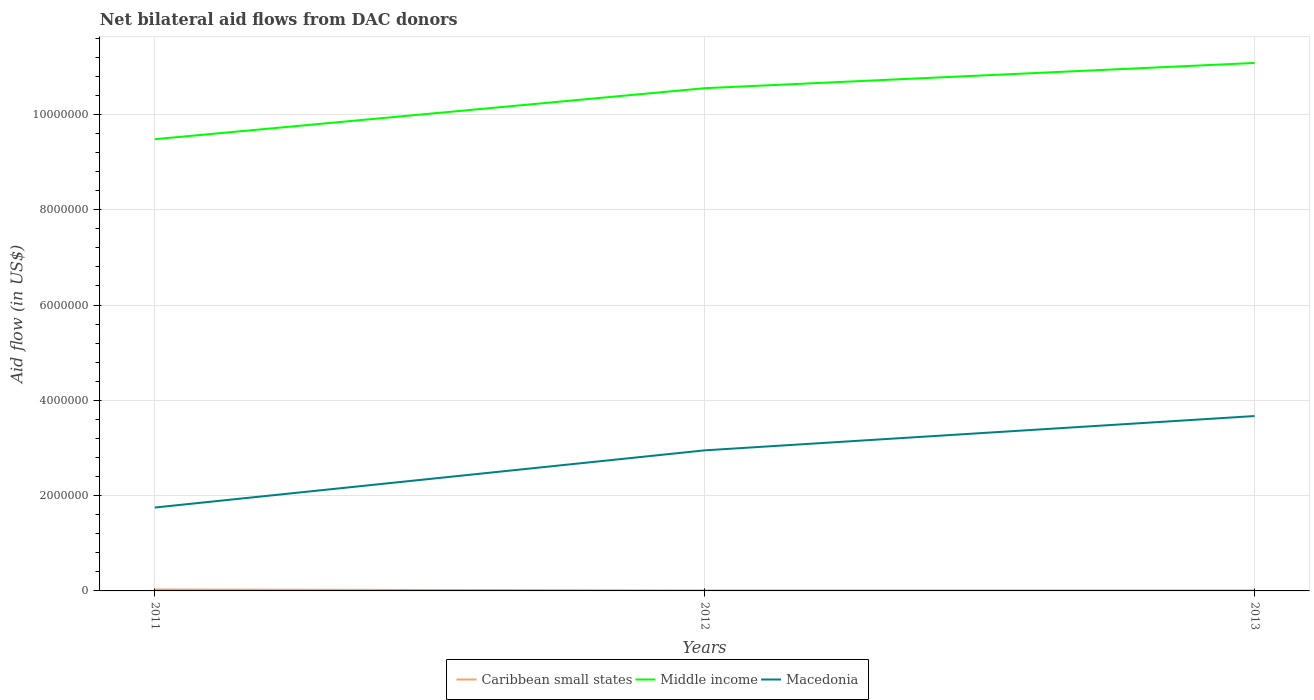Is the number of lines equal to the number of legend labels?
Offer a very short reply. Yes. What is the total net bilateral aid flow in Macedonia in the graph?
Provide a succinct answer. -1.20e+06. What is the difference between the highest and the second highest net bilateral aid flow in Macedonia?
Provide a short and direct response. 1.92e+06. What is the difference between the highest and the lowest net bilateral aid flow in Middle income?
Keep it short and to the point. 2. How many years are there in the graph?
Make the answer very short. 3. What is the difference between two consecutive major ticks on the Y-axis?
Your answer should be very brief. 2.00e+06. Does the graph contain any zero values?
Offer a very short reply. No. Does the graph contain grids?
Your answer should be compact. Yes. How are the legend labels stacked?
Provide a succinct answer. Horizontal. What is the title of the graph?
Keep it short and to the point. Net bilateral aid flows from DAC donors. Does "Sweden" appear as one of the legend labels in the graph?
Your answer should be very brief. No. What is the label or title of the X-axis?
Give a very brief answer. Years. What is the label or title of the Y-axis?
Offer a very short reply. Aid flow (in US$). What is the Aid flow (in US$) of Caribbean small states in 2011?
Your answer should be very brief. 3.00e+04. What is the Aid flow (in US$) in Middle income in 2011?
Your answer should be compact. 9.48e+06. What is the Aid flow (in US$) of Macedonia in 2011?
Keep it short and to the point. 1.75e+06. What is the Aid flow (in US$) of Middle income in 2012?
Offer a terse response. 1.06e+07. What is the Aid flow (in US$) of Macedonia in 2012?
Your answer should be compact. 2.95e+06. What is the Aid flow (in US$) in Caribbean small states in 2013?
Ensure brevity in your answer.  10000. What is the Aid flow (in US$) of Middle income in 2013?
Give a very brief answer. 1.11e+07. What is the Aid flow (in US$) of Macedonia in 2013?
Offer a terse response. 3.67e+06. Across all years, what is the maximum Aid flow (in US$) in Caribbean small states?
Your answer should be compact. 3.00e+04. Across all years, what is the maximum Aid flow (in US$) in Middle income?
Ensure brevity in your answer.  1.11e+07. Across all years, what is the maximum Aid flow (in US$) of Macedonia?
Your answer should be very brief. 3.67e+06. Across all years, what is the minimum Aid flow (in US$) of Middle income?
Provide a succinct answer. 9.48e+06. Across all years, what is the minimum Aid flow (in US$) in Macedonia?
Make the answer very short. 1.75e+06. What is the total Aid flow (in US$) in Caribbean small states in the graph?
Your response must be concise. 5.00e+04. What is the total Aid flow (in US$) in Middle income in the graph?
Your response must be concise. 3.11e+07. What is the total Aid flow (in US$) of Macedonia in the graph?
Provide a succinct answer. 8.37e+06. What is the difference between the Aid flow (in US$) of Middle income in 2011 and that in 2012?
Make the answer very short. -1.07e+06. What is the difference between the Aid flow (in US$) in Macedonia in 2011 and that in 2012?
Make the answer very short. -1.20e+06. What is the difference between the Aid flow (in US$) in Middle income in 2011 and that in 2013?
Provide a short and direct response. -1.60e+06. What is the difference between the Aid flow (in US$) in Macedonia in 2011 and that in 2013?
Your answer should be compact. -1.92e+06. What is the difference between the Aid flow (in US$) of Middle income in 2012 and that in 2013?
Give a very brief answer. -5.30e+05. What is the difference between the Aid flow (in US$) in Macedonia in 2012 and that in 2013?
Offer a terse response. -7.20e+05. What is the difference between the Aid flow (in US$) of Caribbean small states in 2011 and the Aid flow (in US$) of Middle income in 2012?
Provide a succinct answer. -1.05e+07. What is the difference between the Aid flow (in US$) in Caribbean small states in 2011 and the Aid flow (in US$) in Macedonia in 2012?
Provide a succinct answer. -2.92e+06. What is the difference between the Aid flow (in US$) in Middle income in 2011 and the Aid flow (in US$) in Macedonia in 2012?
Ensure brevity in your answer.  6.53e+06. What is the difference between the Aid flow (in US$) of Caribbean small states in 2011 and the Aid flow (in US$) of Middle income in 2013?
Your response must be concise. -1.10e+07. What is the difference between the Aid flow (in US$) of Caribbean small states in 2011 and the Aid flow (in US$) of Macedonia in 2013?
Ensure brevity in your answer.  -3.64e+06. What is the difference between the Aid flow (in US$) in Middle income in 2011 and the Aid flow (in US$) in Macedonia in 2013?
Make the answer very short. 5.81e+06. What is the difference between the Aid flow (in US$) in Caribbean small states in 2012 and the Aid flow (in US$) in Middle income in 2013?
Your answer should be very brief. -1.11e+07. What is the difference between the Aid flow (in US$) in Caribbean small states in 2012 and the Aid flow (in US$) in Macedonia in 2013?
Provide a succinct answer. -3.66e+06. What is the difference between the Aid flow (in US$) in Middle income in 2012 and the Aid flow (in US$) in Macedonia in 2013?
Give a very brief answer. 6.88e+06. What is the average Aid flow (in US$) of Caribbean small states per year?
Your answer should be very brief. 1.67e+04. What is the average Aid flow (in US$) of Middle income per year?
Keep it short and to the point. 1.04e+07. What is the average Aid flow (in US$) in Macedonia per year?
Your answer should be compact. 2.79e+06. In the year 2011, what is the difference between the Aid flow (in US$) in Caribbean small states and Aid flow (in US$) in Middle income?
Provide a succinct answer. -9.45e+06. In the year 2011, what is the difference between the Aid flow (in US$) in Caribbean small states and Aid flow (in US$) in Macedonia?
Your answer should be very brief. -1.72e+06. In the year 2011, what is the difference between the Aid flow (in US$) in Middle income and Aid flow (in US$) in Macedonia?
Offer a terse response. 7.73e+06. In the year 2012, what is the difference between the Aid flow (in US$) in Caribbean small states and Aid flow (in US$) in Middle income?
Provide a short and direct response. -1.05e+07. In the year 2012, what is the difference between the Aid flow (in US$) of Caribbean small states and Aid flow (in US$) of Macedonia?
Your answer should be compact. -2.94e+06. In the year 2012, what is the difference between the Aid flow (in US$) in Middle income and Aid flow (in US$) in Macedonia?
Provide a succinct answer. 7.60e+06. In the year 2013, what is the difference between the Aid flow (in US$) in Caribbean small states and Aid flow (in US$) in Middle income?
Offer a terse response. -1.11e+07. In the year 2013, what is the difference between the Aid flow (in US$) of Caribbean small states and Aid flow (in US$) of Macedonia?
Make the answer very short. -3.66e+06. In the year 2013, what is the difference between the Aid flow (in US$) in Middle income and Aid flow (in US$) in Macedonia?
Ensure brevity in your answer.  7.41e+06. What is the ratio of the Aid flow (in US$) of Caribbean small states in 2011 to that in 2012?
Ensure brevity in your answer.  3. What is the ratio of the Aid flow (in US$) in Middle income in 2011 to that in 2012?
Give a very brief answer. 0.9. What is the ratio of the Aid flow (in US$) in Macedonia in 2011 to that in 2012?
Keep it short and to the point. 0.59. What is the ratio of the Aid flow (in US$) in Middle income in 2011 to that in 2013?
Provide a short and direct response. 0.86. What is the ratio of the Aid flow (in US$) in Macedonia in 2011 to that in 2013?
Your response must be concise. 0.48. What is the ratio of the Aid flow (in US$) of Middle income in 2012 to that in 2013?
Your response must be concise. 0.95. What is the ratio of the Aid flow (in US$) of Macedonia in 2012 to that in 2013?
Offer a terse response. 0.8. What is the difference between the highest and the second highest Aid flow (in US$) of Caribbean small states?
Give a very brief answer. 2.00e+04. What is the difference between the highest and the second highest Aid flow (in US$) in Middle income?
Your answer should be compact. 5.30e+05. What is the difference between the highest and the second highest Aid flow (in US$) of Macedonia?
Offer a terse response. 7.20e+05. What is the difference between the highest and the lowest Aid flow (in US$) in Middle income?
Give a very brief answer. 1.60e+06. What is the difference between the highest and the lowest Aid flow (in US$) in Macedonia?
Your answer should be very brief. 1.92e+06. 